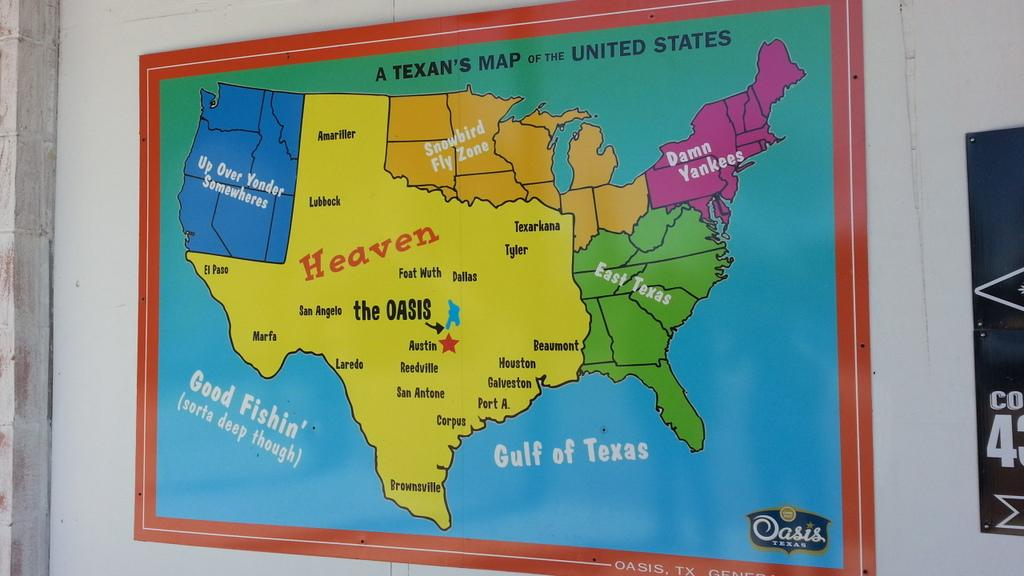Provide a one-sentence caption for the provided image. A large colored map of a Texan's Map of the United States. 